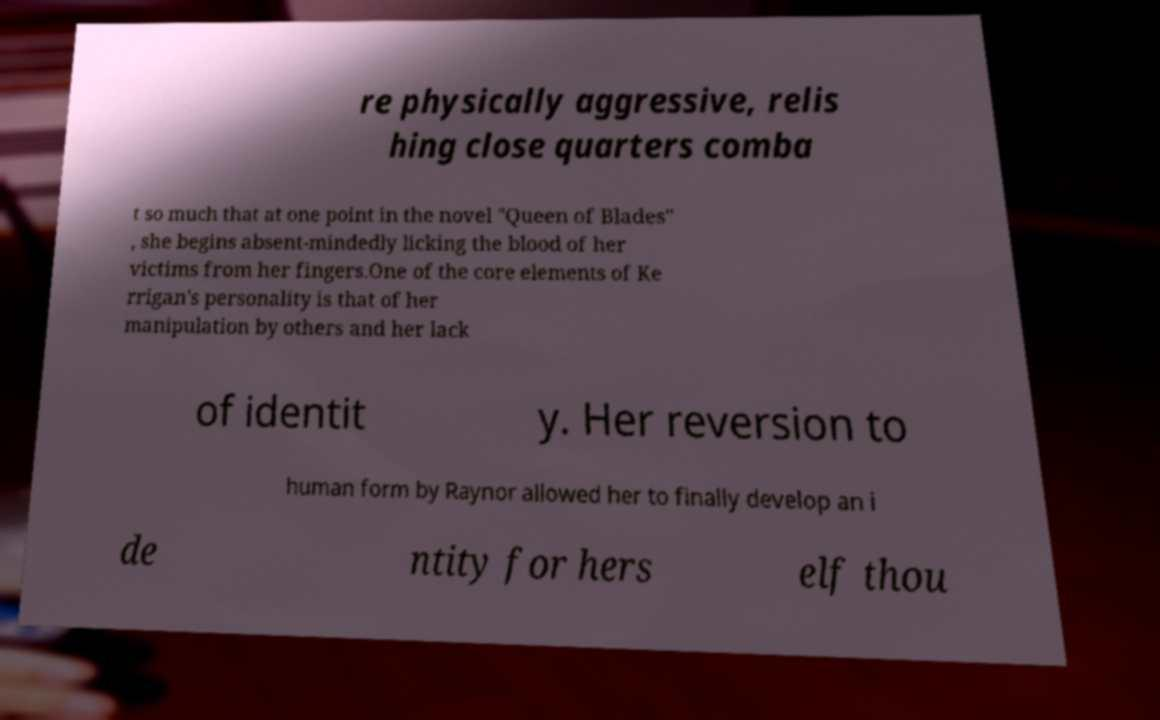Can you read and provide the text displayed in the image?This photo seems to have some interesting text. Can you extract and type it out for me? re physically aggressive, relis hing close quarters comba t so much that at one point in the novel "Queen of Blades" , she begins absent-mindedly licking the blood of her victims from her fingers.One of the core elements of Ke rrigan's personality is that of her manipulation by others and her lack of identit y. Her reversion to human form by Raynor allowed her to finally develop an i de ntity for hers elf thou 